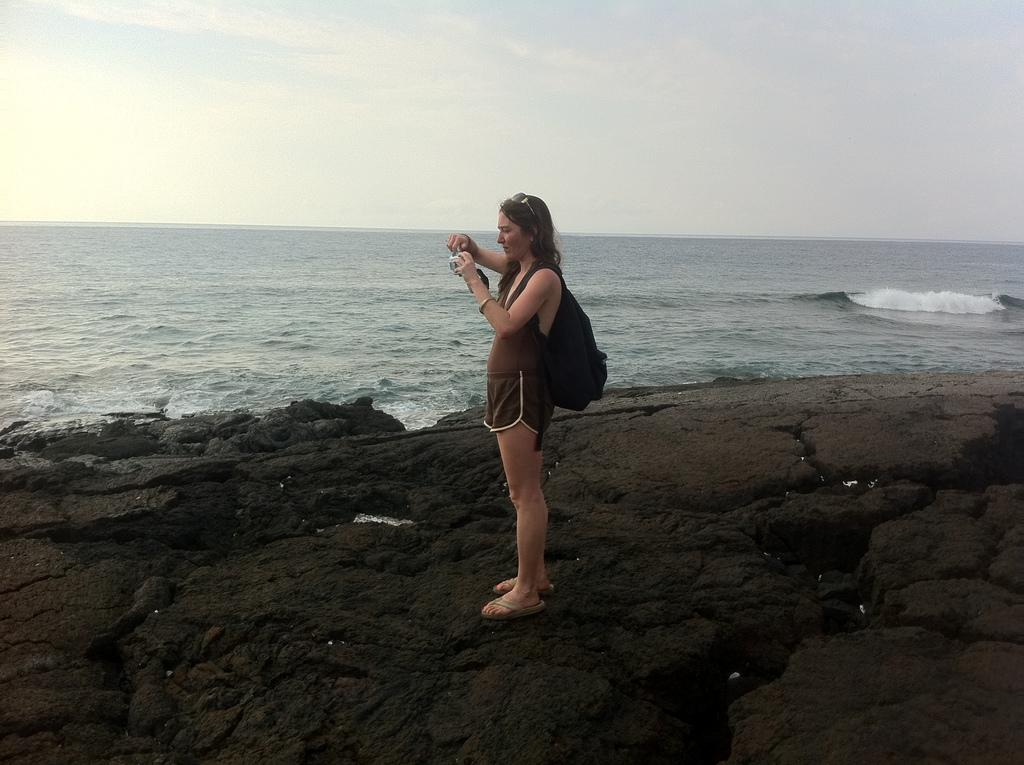Where was the image taken? The image was taken at the beach. Who is present in the image? There is a woman in the image. What is the woman wearing? The woman is wearing a bag. What is the woman doing in the image? The woman is standing. What type of natural features can be seen in the image? There are rocks visible in the image. What is visible in the background of the image? The sky is visible in the image. What type of road can be seen in the image? There is no road present in the image; it was taken at the beach. What kind of boot is the woman wearing in the image? The woman is not wearing a boot in the image; she is wearing a bag. 